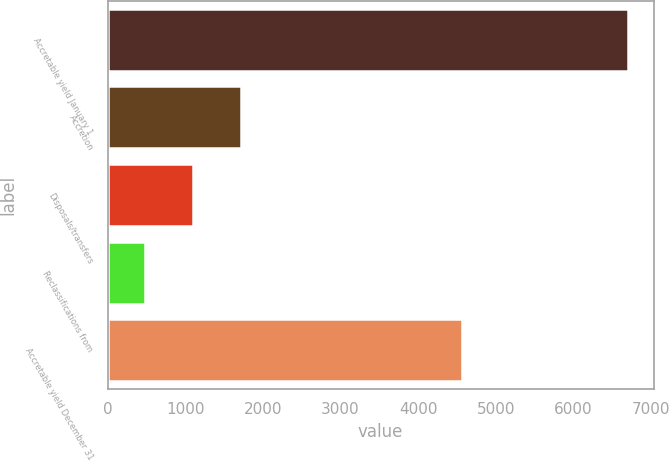<chart> <loc_0><loc_0><loc_500><loc_500><bar_chart><fcel>Accretable yield January 1<fcel>Accretion<fcel>Disposals/transfers<fcel>Reclassifications from<fcel>Accretable yield December 31<nl><fcel>6694<fcel>1723.6<fcel>1102.3<fcel>481<fcel>4569<nl></chart> 